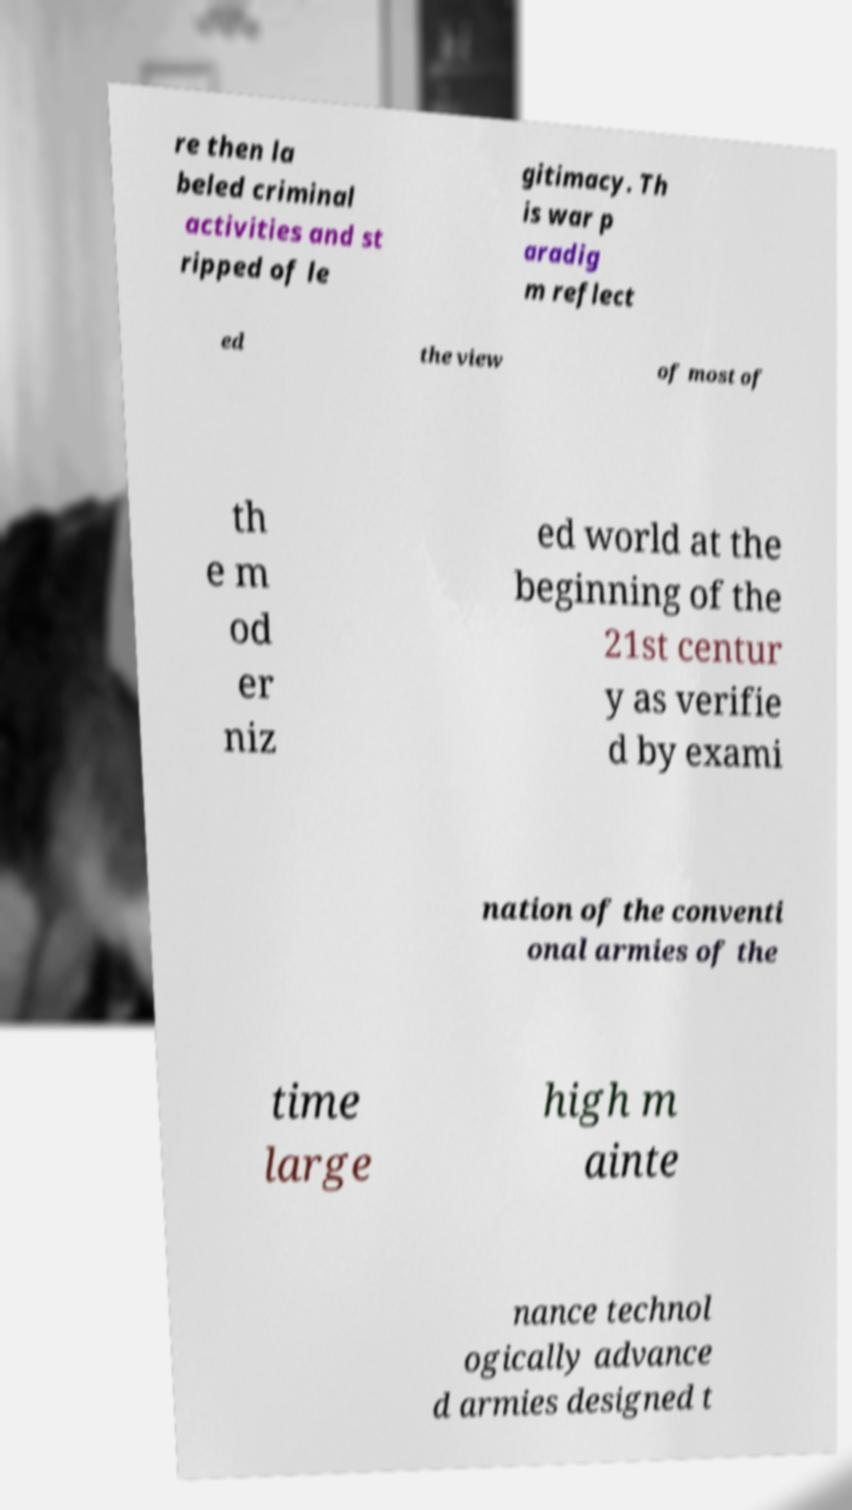For documentation purposes, I need the text within this image transcribed. Could you provide that? re then la beled criminal activities and st ripped of le gitimacy. Th is war p aradig m reflect ed the view of most of th e m od er niz ed world at the beginning of the 21st centur y as verifie d by exami nation of the conventi onal armies of the time large high m ainte nance technol ogically advance d armies designed t 